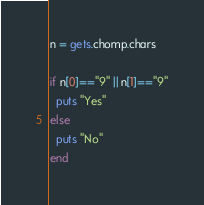Convert code to text. <code><loc_0><loc_0><loc_500><loc_500><_Ruby_>n = gets.chomp.chars

if n[0]=="9" || n[1]=="9"
  puts "Yes"
else
  puts "No"
end</code> 